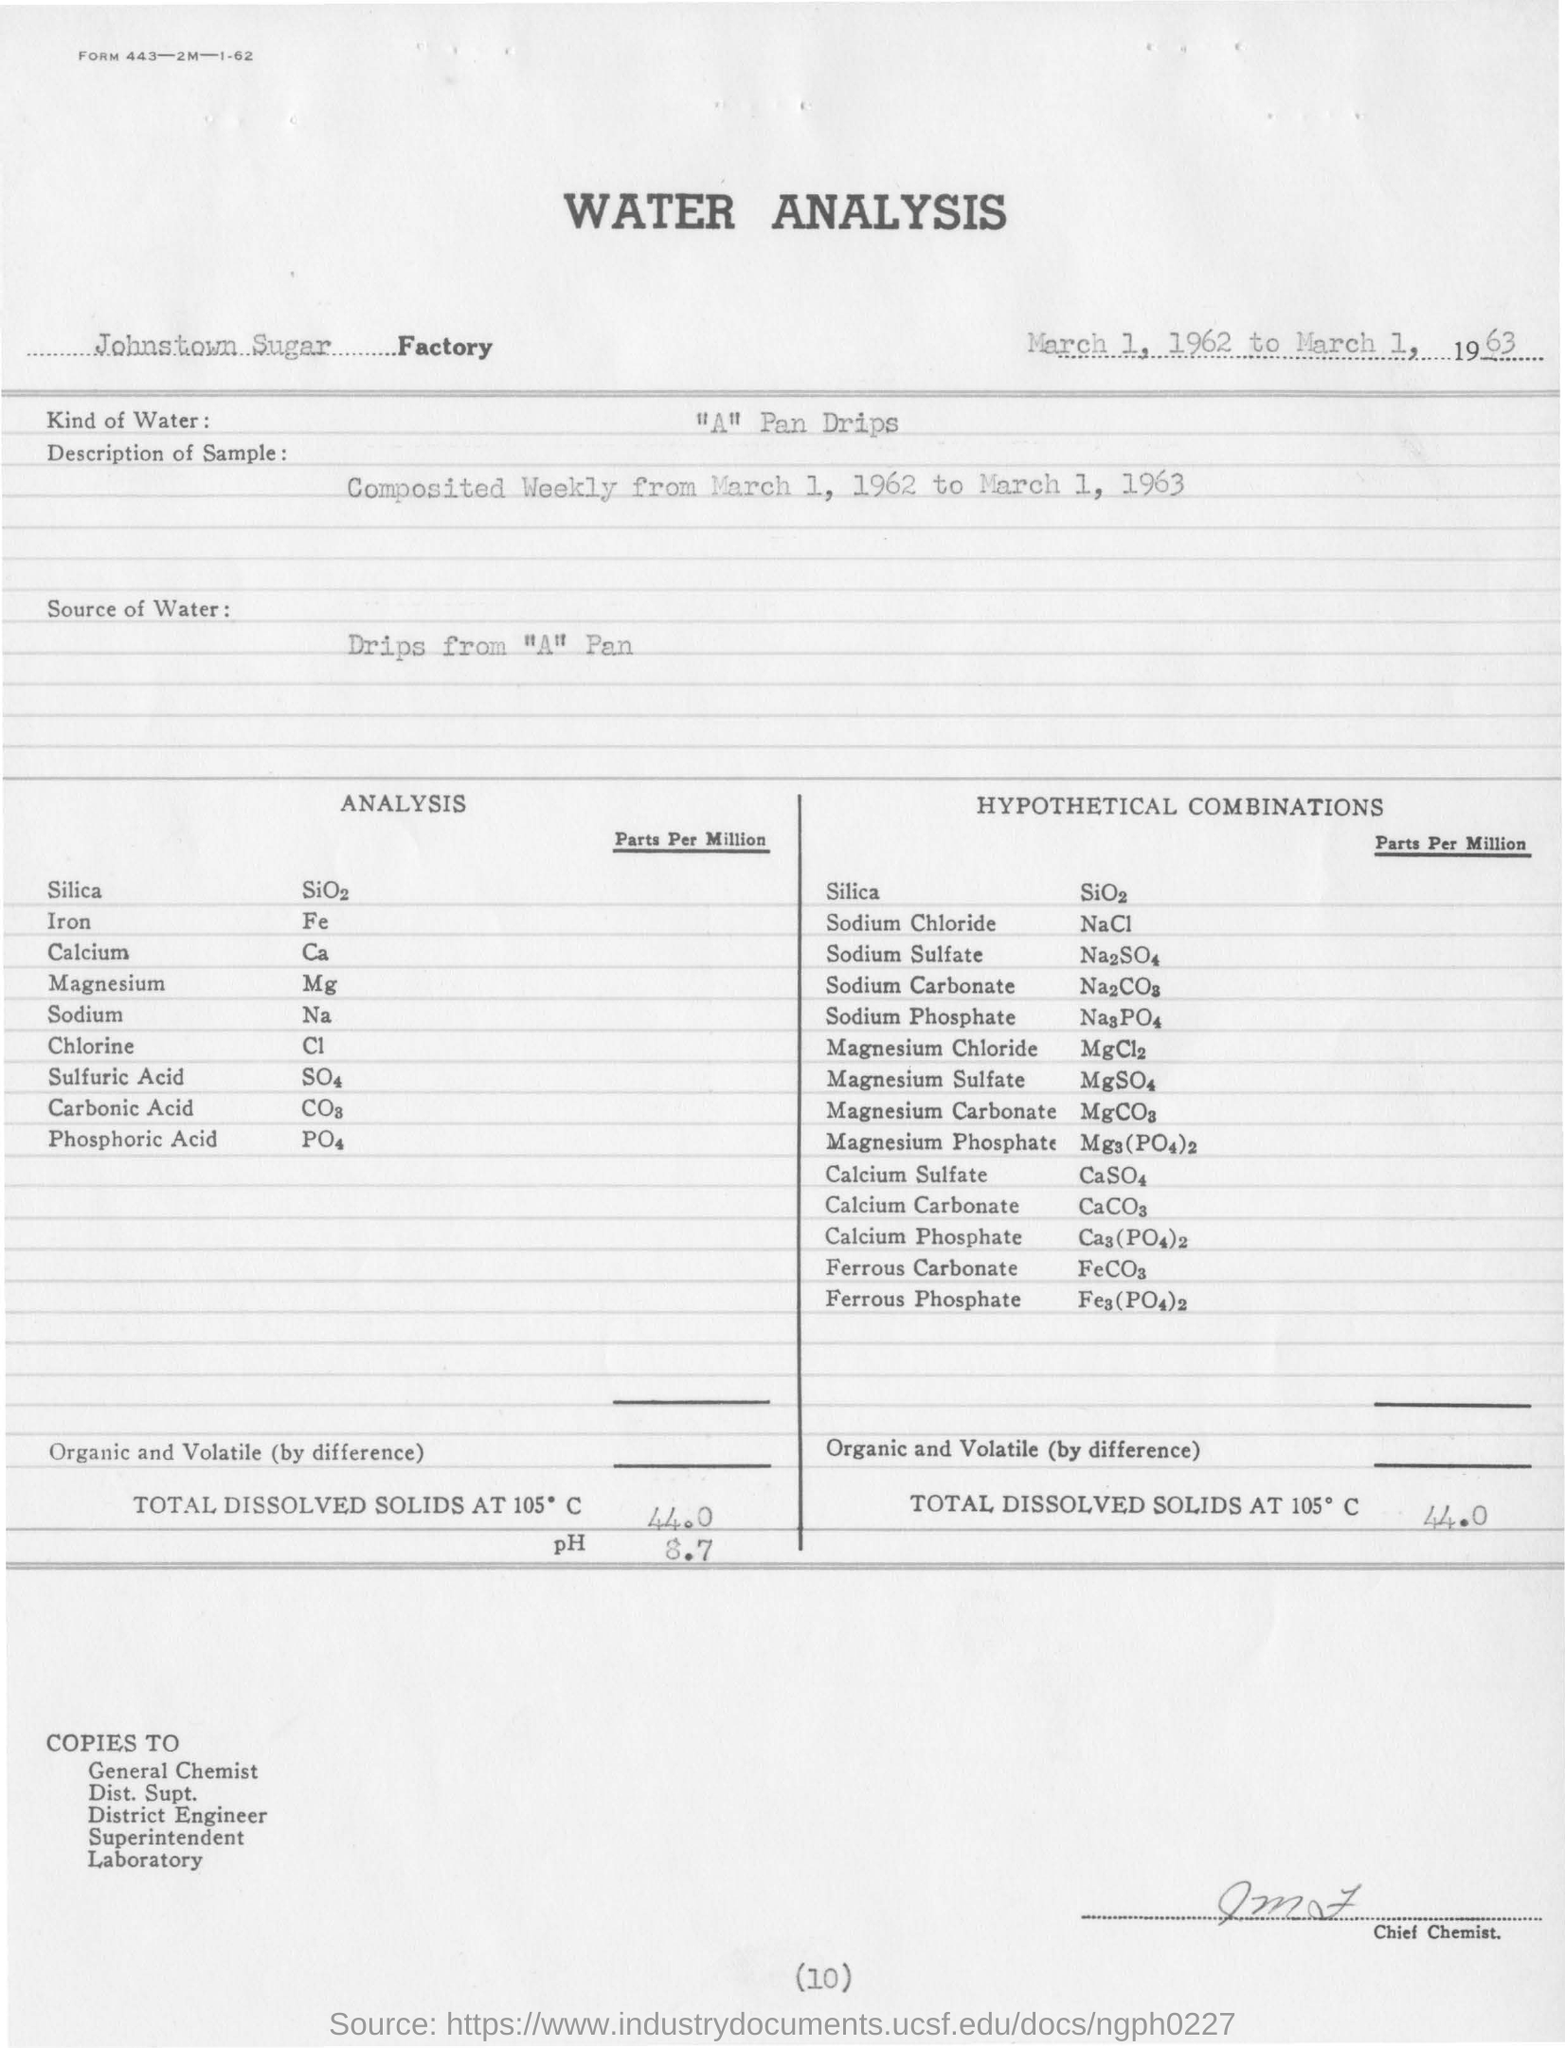Give some essential details in this illustration. The type of water used in the analysis is "A" Pan Drips. The pH value for total dissolved solids at 105 degrees Celsius is 8.7. Johnstown Sugar Factory is the name of the factory. The amount of total dissolved solids at 105 degrees Celsius is 44.0 grams. 